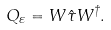Convert formula to latex. <formula><loc_0><loc_0><loc_500><loc_500>Q _ { \varepsilon } = W { \hat { \tau } } W ^ { \dagger } .</formula> 